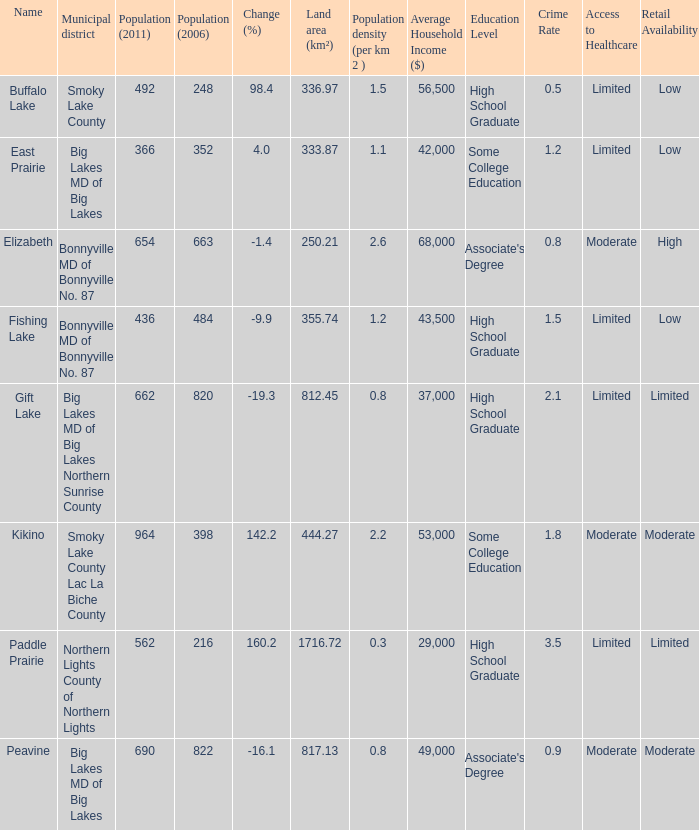What is the density per km in Smoky Lake County? 1.5. 